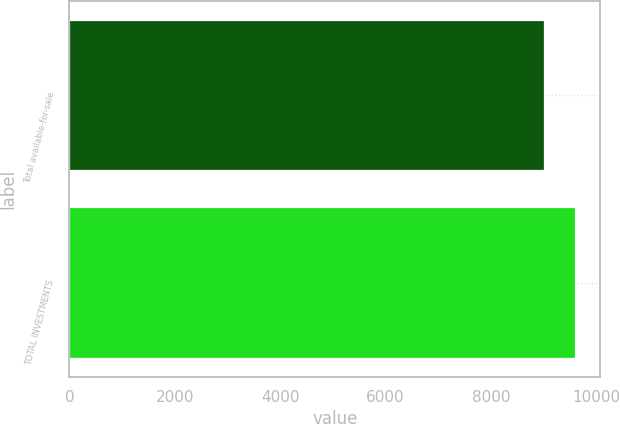<chart> <loc_0><loc_0><loc_500><loc_500><bar_chart><fcel>Total available-for-sale<fcel>TOTAL INVESTMENTS<nl><fcel>9008<fcel>9597<nl></chart> 